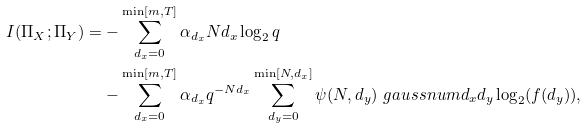<formula> <loc_0><loc_0><loc_500><loc_500>I ( \Pi _ { X } ; \Pi _ { Y } ) = & - \sum _ { d _ { x } = 0 } ^ { \min [ m , T ] } \alpha _ { d _ { x } } N d _ { x } \log _ { 2 } { q } \\ & - \sum _ { d _ { x } = 0 } ^ { \min [ m , T ] } \alpha _ { d _ { x } } q ^ { - N d _ { x } } \sum _ { d _ { y } = 0 } ^ { \min [ N , d _ { x } ] } \psi ( N , d _ { y } ) \ g a u s s n u m { d _ { x } } { d _ { y } } \log _ { 2 } ( f ( d _ { y } ) ) ,</formula> 